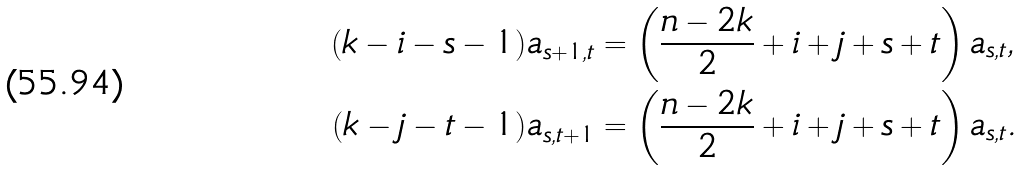<formula> <loc_0><loc_0><loc_500><loc_500>( k - i - s - 1 ) a _ { s + 1 , t } & = \left ( \frac { n - 2 k } { 2 } + i + j + s + t \right ) a _ { s , t } , \\ ( k - j - t - 1 ) a _ { s , t + 1 } & = \left ( \frac { n - 2 k } { 2 } + i + j + s + t \right ) a _ { s , t } .</formula> 